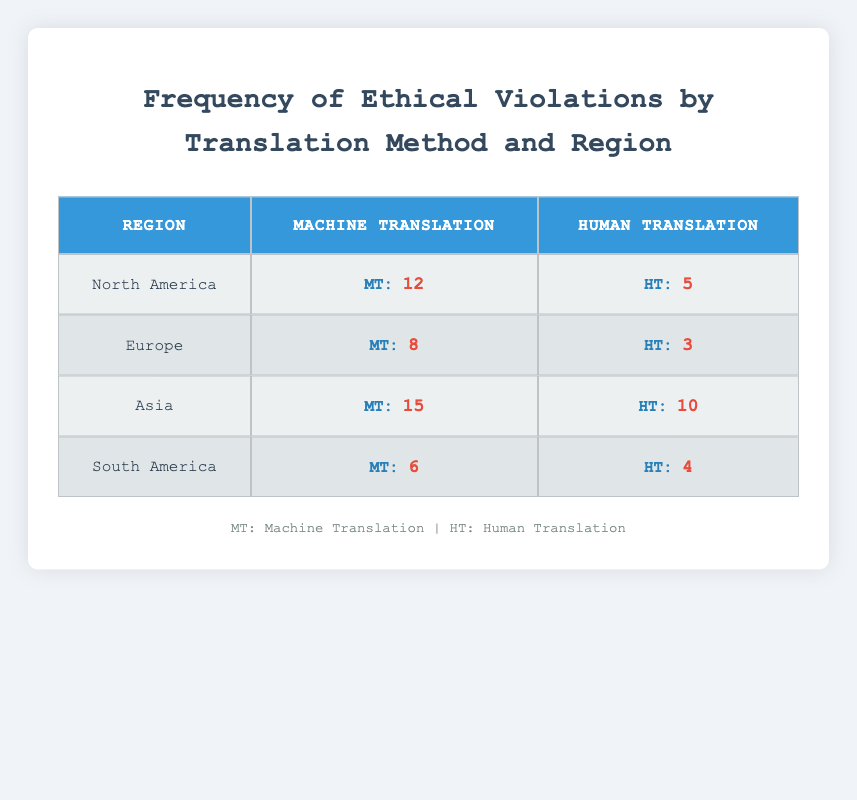What is the highest number of ethical violations reported for machine translation across all regions? The table shows that Asia has the highest number of ethical violations for machine translation, with a count of 15.
Answer: 15 Which region has reported the lowest ethical violations for human translation? By comparing the values for human translation across regions, Europe has the lowest count of ethical violations, which is 3.
Answer: 3 What is the total number of ethical violations for machine translation in North America and South America combined? Adding the counts for machine translation in North America (12) and South America (6) yields a total of 12 + 6 = 18.
Answer: 18 Is the number of ethical violations for human translation in Asia greater than that in Europe? The table shows 10 ethical violations for human translation in Asia and 3 in Europe, confirming that Asia has a higher count.
Answer: Yes What is the difference in ethical violations for machine translation between North America and South America? The counts for machine translation are 12 for North America and 6 for South America. The difference is 12 - 6 = 6.
Answer: 6 Which translation method has a higher overall total of ethical violations across all regions? Calculating the totals: Machine Translation: 12 + 8 + 15 + 6 = 41; Human Translation: 5 + 3 + 10 + 4 = 22. Machine Translation has a higher overall total.
Answer: Machine Translation What is the average number of ethical violations for human translation across all regions? Adding the counts for human translation: 5 + 3 + 10 + 4 = 22, and dividing by the number of regions (4), gives an average of 22 / 4 = 5.5.
Answer: 5.5 Does North America have more ethical violations for machine translation than Asia? North America has 12 violations for machine translation and Asia has 15, meaning North America does not have more.
Answer: No What is the total number of ethical violations reported for human translation in all regions? Summing the counts for human translation: 5 + 3 + 10 + 4 = 22 gives the total number of ethical violations.
Answer: 22 